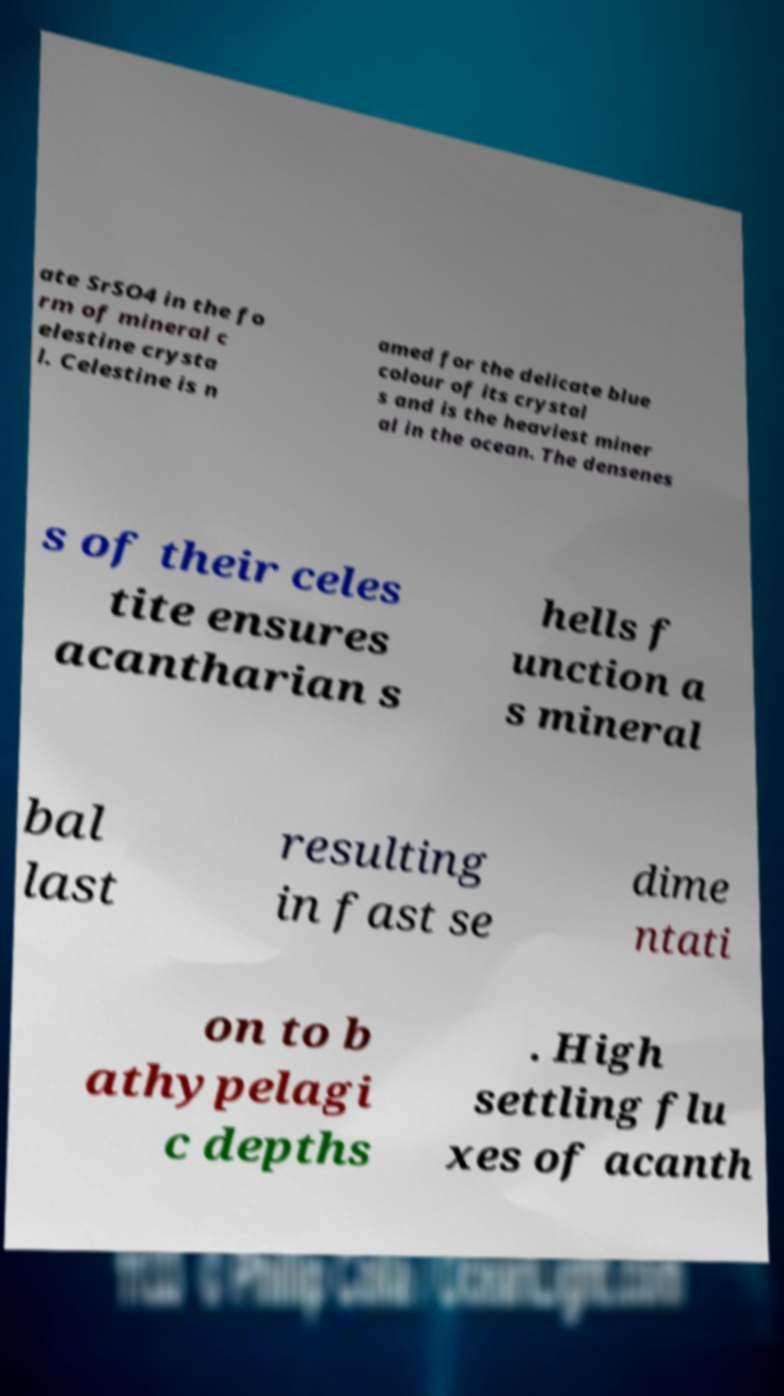For documentation purposes, I need the text within this image transcribed. Could you provide that? ate SrSO4 in the fo rm of mineral c elestine crysta l. Celestine is n amed for the delicate blue colour of its crystal s and is the heaviest miner al in the ocean. The densenes s of their celes tite ensures acantharian s hells f unction a s mineral bal last resulting in fast se dime ntati on to b athypelagi c depths . High settling flu xes of acanth 